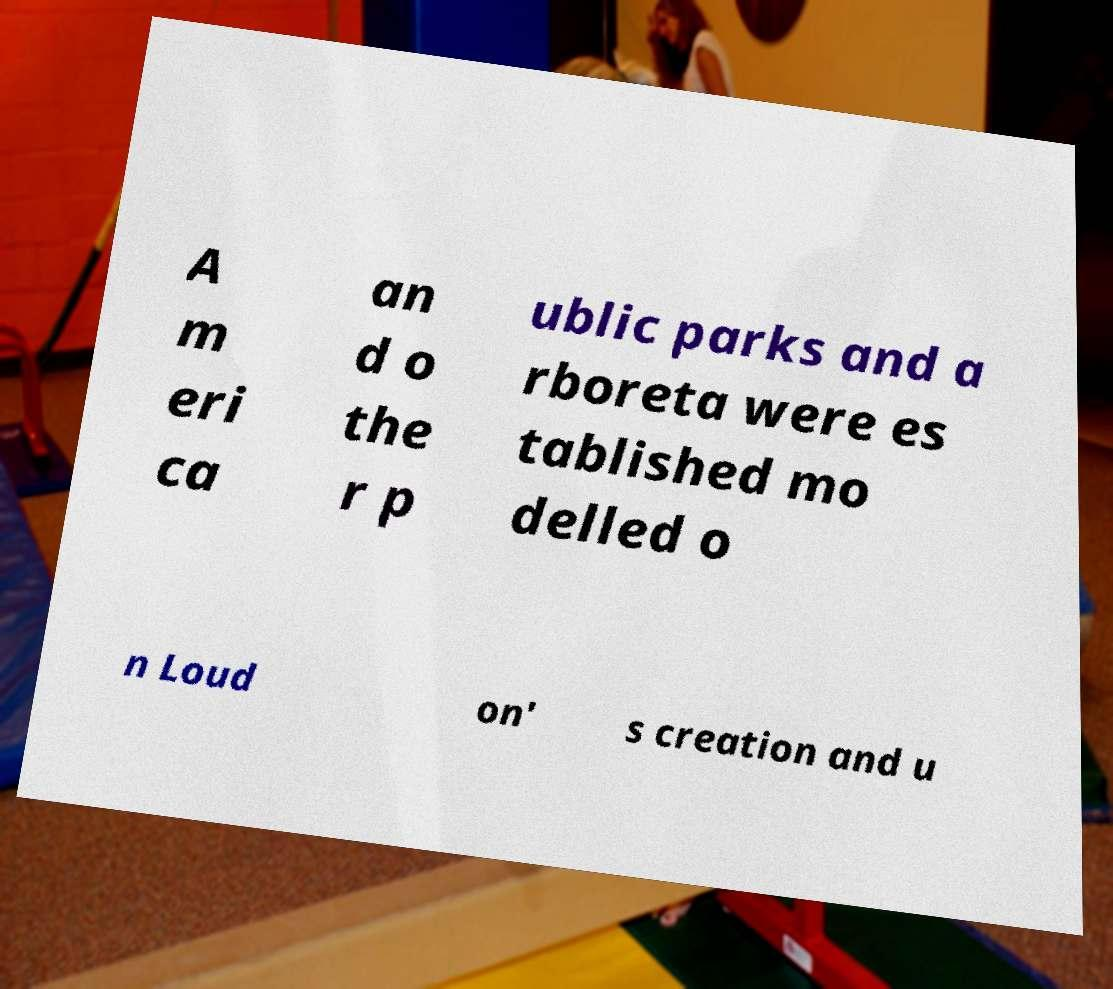Can you accurately transcribe the text from the provided image for me? A m eri ca an d o the r p ublic parks and a rboreta were es tablished mo delled o n Loud on' s creation and u 